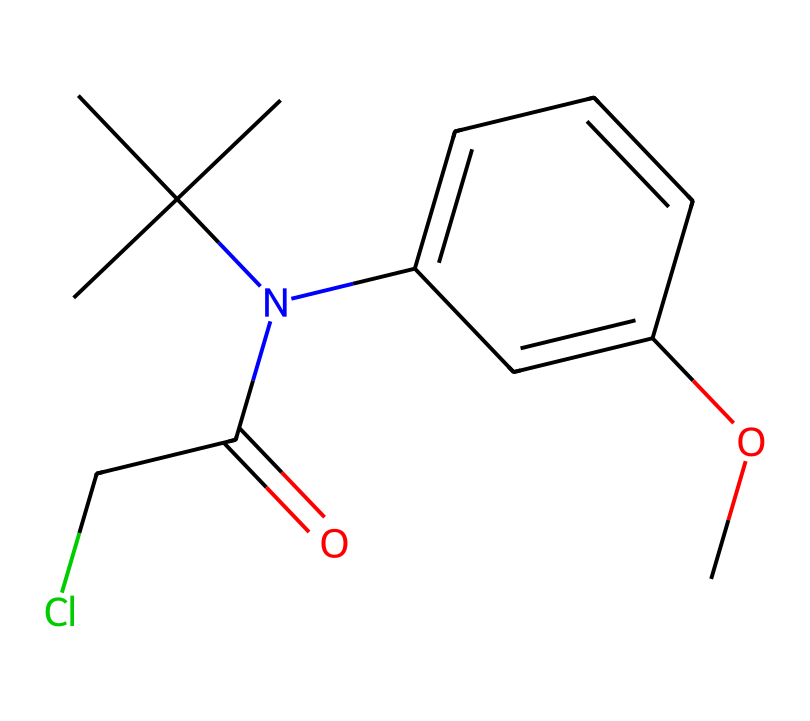What is the molecular formula of this compound? By analyzing the structure represented in the SMILES notation, we can identify the number of each type of atom. Counting carbon (C), nitrogen (N), oxygen (O), and chlorine (Cl) gives us a total of 14 carbons, 1 nitrogen, 1 oxygen, and 1 chlorine. Therefore, the molecular formula is C14H20ClNO.
Answer: C14H20ClNO How many chiral centers are in this compound? A chiral center is typically a carbon atom that is attached to four different groups. In the structure represented by the SMILES, we can identify one carbon atom that meets the criterion of being bonded to four distinct substituents, indicating that there is one chiral center present.
Answer: 1 What type of functionality does the nitrogen in this compound represent? The nitrogen in the compound is part of an amine functional group due to its bonding to carbon atoms and a non-bonded pair of electrons. It indicates that this compound is a tertiary amine, impacting its chemical behavior and interactions.
Answer: tertiary amine How can chirality affect the pesticide's efficacy? Chirality can greatly influence the biological activity of pesticides because only one enantiomer of a chiral compound might bind effectively to the target enzyme or receptor, while the other could be inactive or even harmful. This specificity can determine the effectiveness and safety profile of the pesticide.
Answer: efficacy What kind of agricultural policy might arise from the use of chiral pesticides? The use of chiral pesticides may lead to regulations focusing on environmental impact assessments, as chirality can significantly affect toxicity and biodegradability. Policies may prioritize chiral compounds that exhibit lower toxicity to non-target organisms while maintaining efficacy against pests.
Answer: regulations focusing on environmental impact assessments How does the presence of chlorine in pesticides influence global agricultural policies? Chlorine's presence in pesticides often raises concerns regarding environmental safety and human health. This can lead to stricter regulatory frameworks and bans on certain products, prompting shifts in agricultural practices globally to find safer alternatives.
Answer: stricter regulatory frameworks 